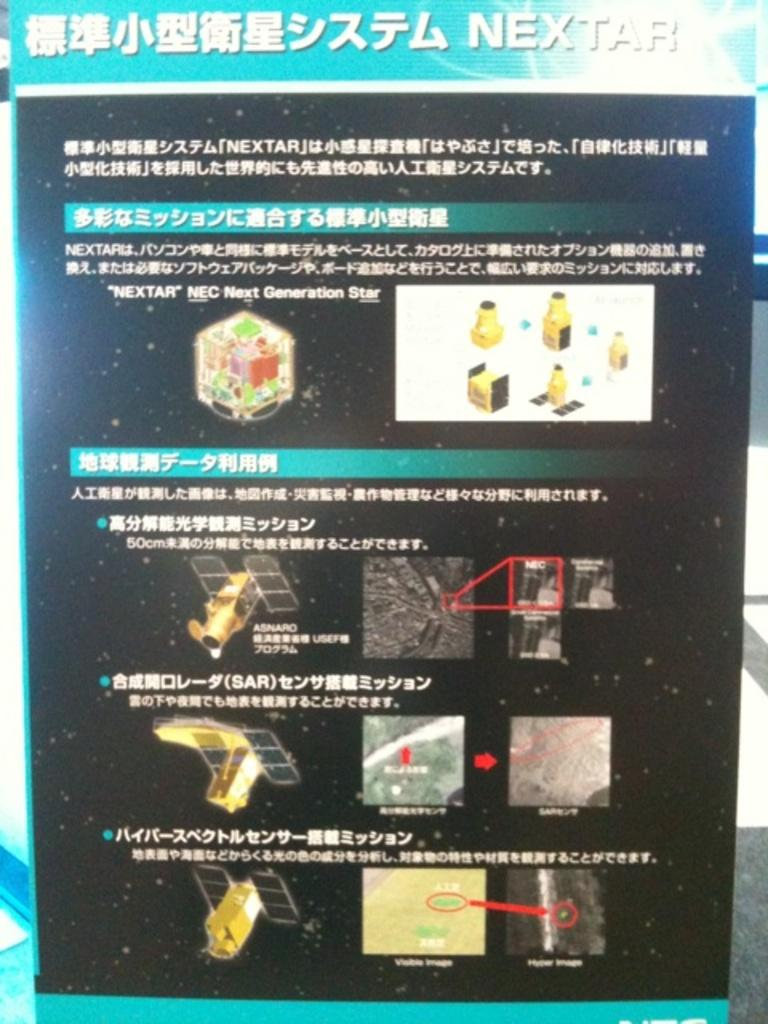What is present on the table in the image? There is a poster on the table in the image. What is depicted on the poster? The poster contains images of satellites. What language is used at the top of the poster? There is Chinese language text at the top of the poster. Can you tell me how many chess pieces are on the table in the image? There are no chess pieces present in the image; it features a poster with images of satellites. Is there a tiger visible in the image? There is no tiger present in the image. 